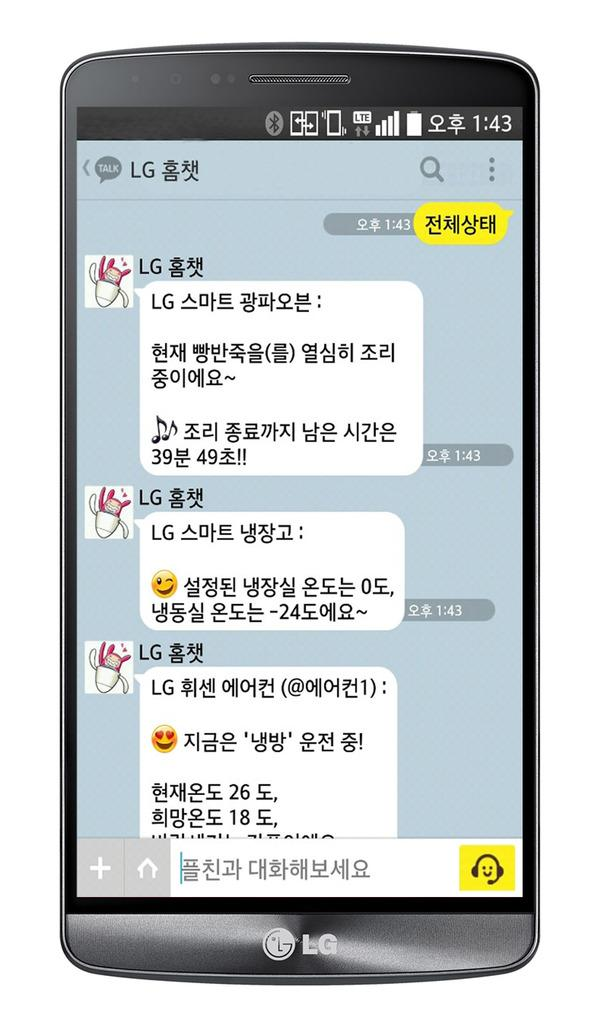<image>
Write a terse but informative summary of the picture. a black and silver lg phone with the time reading 1:43 on it 